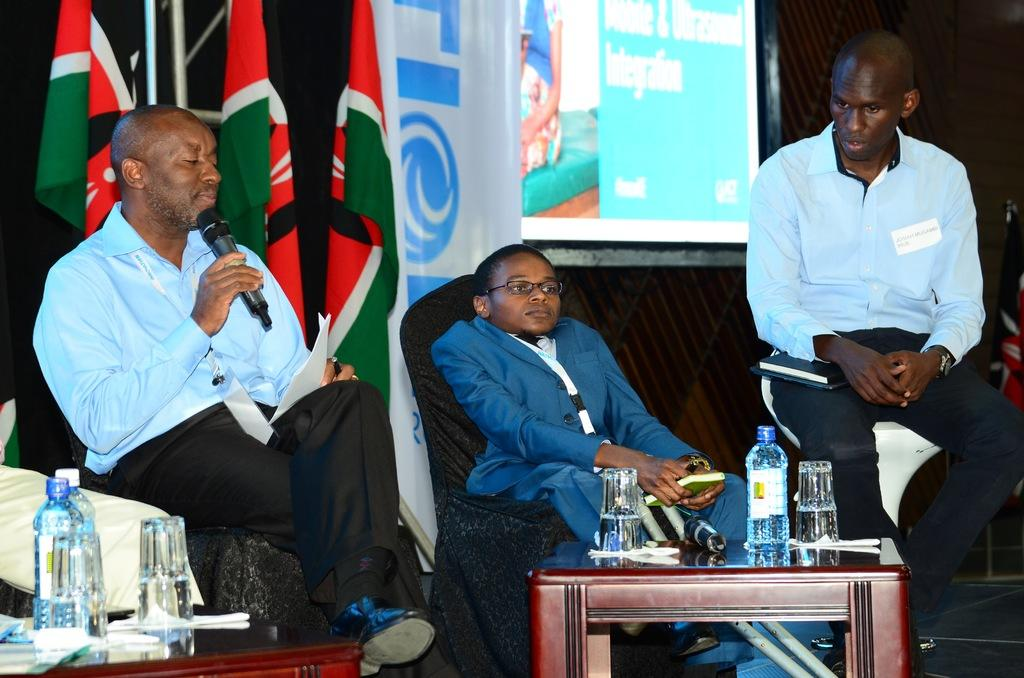How many people are sitting on a seating object in the image? There are three people sitting in the image, two on a sofa and one on a stool. What is the person on the stool sitting on? The person on the stool is sitting on a stool. Can you identify any objects related to hydration in the image? Yes, there is a water bottle in the image. What type of cactus is located behind the sofa in the image? There is no cactus present in the image. 